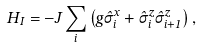Convert formula to latex. <formula><loc_0><loc_0><loc_500><loc_500>H _ { I } = - J \sum _ { i } \left ( g \hat { \sigma } ^ { x } _ { i } + \hat { \sigma } ^ { z } _ { i } \hat { \sigma } ^ { z } _ { i + 1 } \right ) ,</formula> 